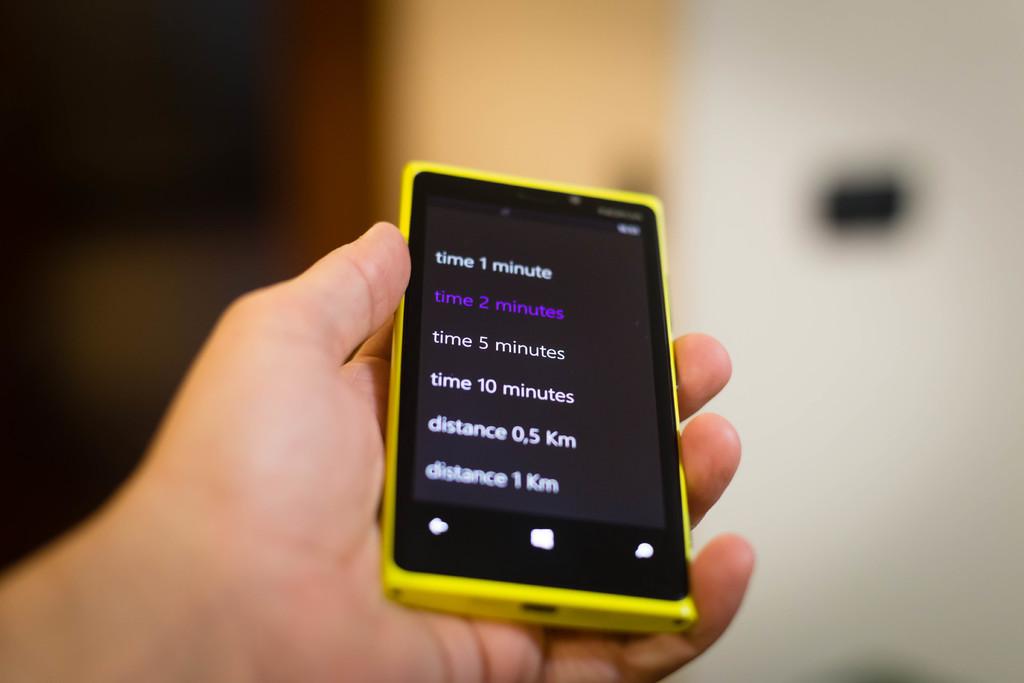How long is the selected timer?
Provide a succinct answer. 2 minutes. What distance is mentioned?
Provide a succinct answer. 0.5 km and 1 km. 